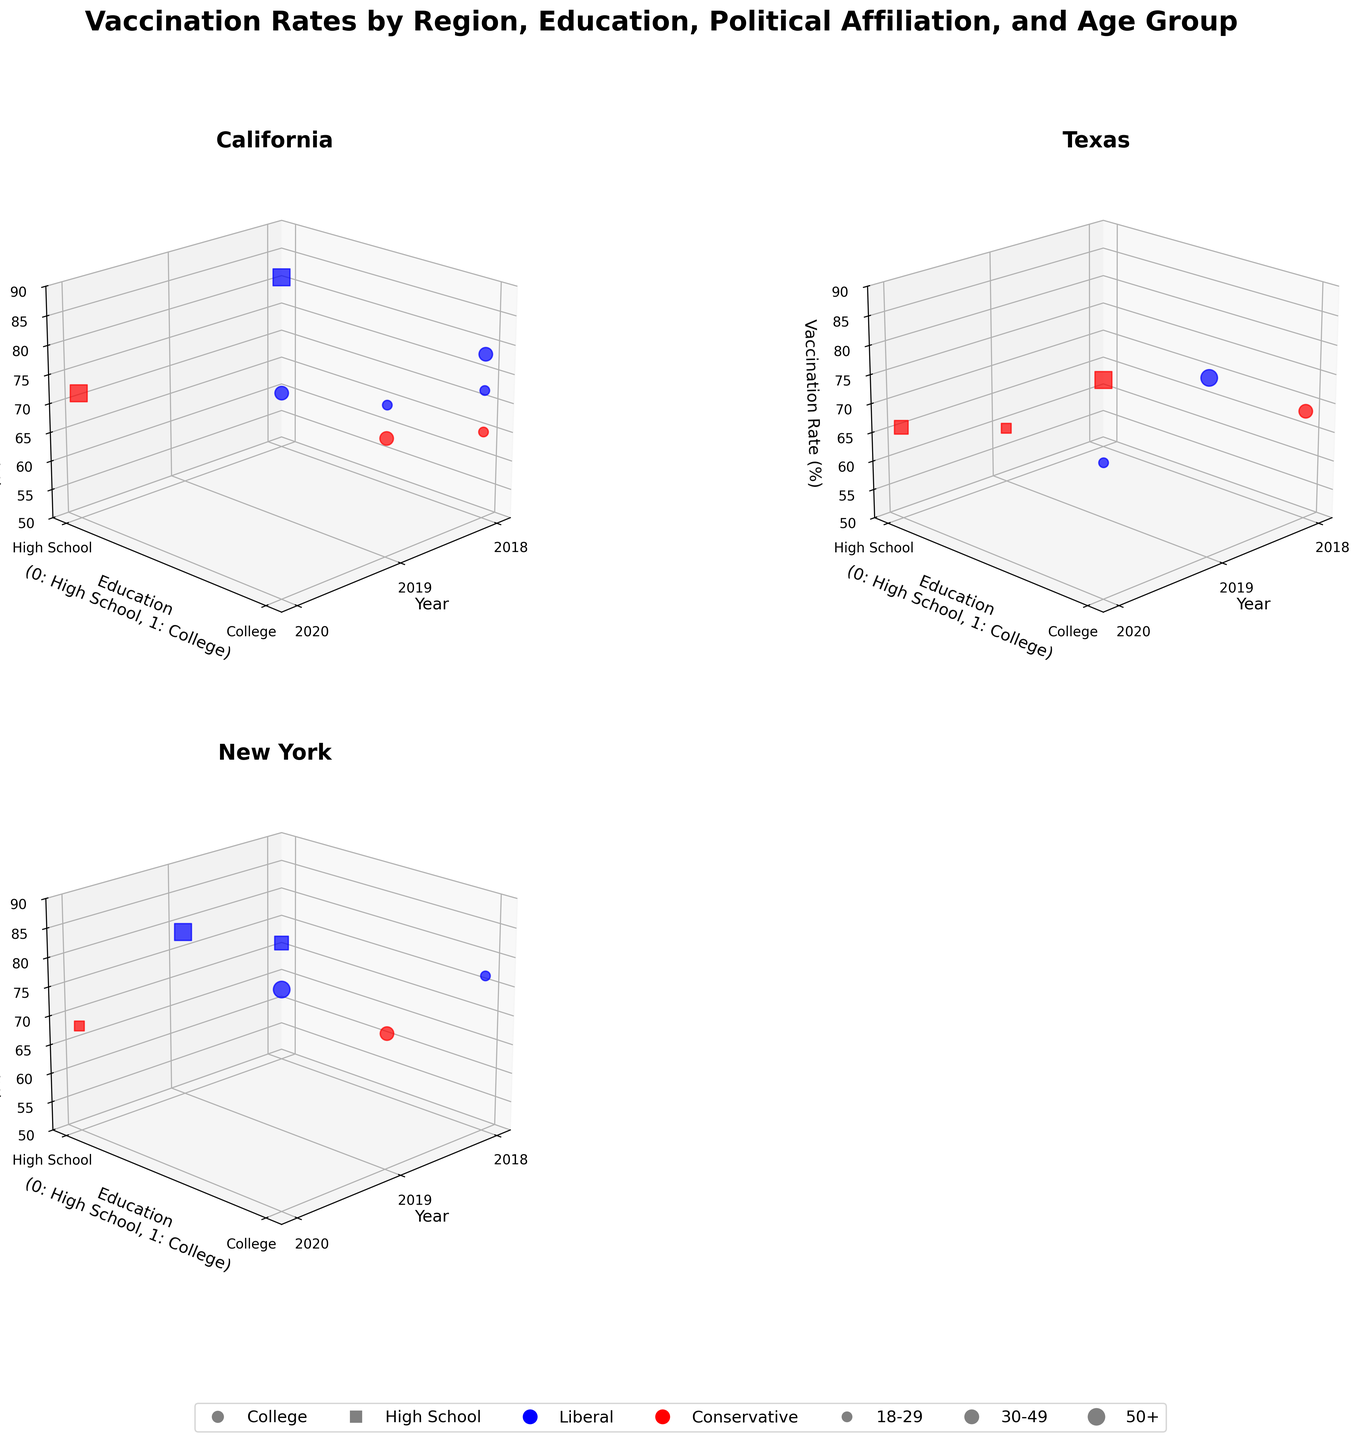Which region has the highest vaccination rate in 2020? Look at the scatter points for all regions in 2020. For New York, there is a point with a vaccination rate of 86.2%.
Answer: New York What is the vaccination rate for liberal college-educated 30-49 year-olds in California in 2020? Identify the point in the California subplot for 2020 where the education level is college (1), political affiliation is liberal (blue), and age group is 30-49 (represented by a larger scatter marker). The vaccination rate is 83.7%.
Answer: 83.7% How does the vaccination rate for conservative high school-educated individuals aged 18-29 in Texas change from 2018 to 2019? Compare the scatter points for Texas with conservative high school education and 18-29 age group between 2018 and 2019. The rate decreases from 62.4% to 59.6%.
Answer: Decrease by 2.8% Which group has the largest vaccination rate increase in New York from 2019 to 2020? Look at the differences in vaccination rates for different groups in New York between 2019 and 2020. The college-educated liberals (50+) increase from 78.9% to 86.2%, a rise of 7.3%.
Answer: College-educated liberals (50+) Does the vaccination rate for college-educated liberals aged 18-29 increase or decrease over the years in California? Observe the points for college-educated liberals aged 18-29 in California across the years 2018 (72.3%), 2019 (75.8%), and 2020 (not present). The rate increases from 2018 to 2019.
Answer: Increase In which year and for which specific group did California have the highest vaccination rate? Search for the highest point in the California subplot. In 2020, college-educated liberals aged 30-49 have the highest rate at 83.7%.
Answer: 2020, college-educated liberals aged 30-49 What is the overall trend in vaccination rates for liberal college-educated groups across all regions over the years? Examine the scatter points for liberal college-educated groups across all years in each region. Generally, there is an increasing trend.
Answer: Increasing trend Between California and Texas, which state has a higher vaccination rate for conservative high school-educated individuals aged 50+ in 2018? Compare the points: in California, it's 81.2%, whereas in Texas, it's 62.4%.
Answer: California How does the vaccination rate for high school-educated liberals aged 50+ in New York change from 2018 to 2019? Check the rates for 2018 (81.2%) and 2019 (78.9%), showing a decrease.
Answer: Decreased by 2.3% Which region has the most consistent vaccination rates over the observed years? Compare the scatter point dispersions for each region. Texas has the least variation, indicating consistency.
Answer: Texas 